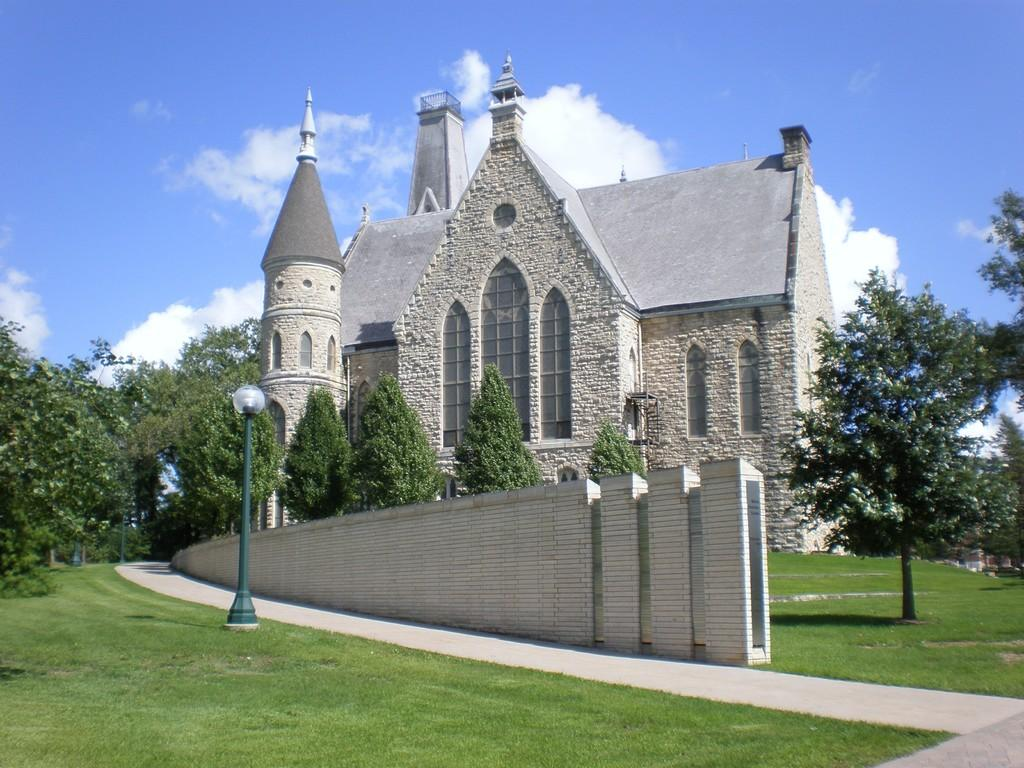What type of structure is visible in the image? There is a house in the image. What features can be seen on the house? The house has windows. What other objects are present in the image? There is a light pole, plants, trees, and a wall in the image. What part of the natural environment is visible in the image? The sky is visible in the image. Can you see any ants crawling on the house in the image? There are no ants visible in the image. What type of cable is connected to the light pole in the image? There is no cable connected to the light pole in the image. 